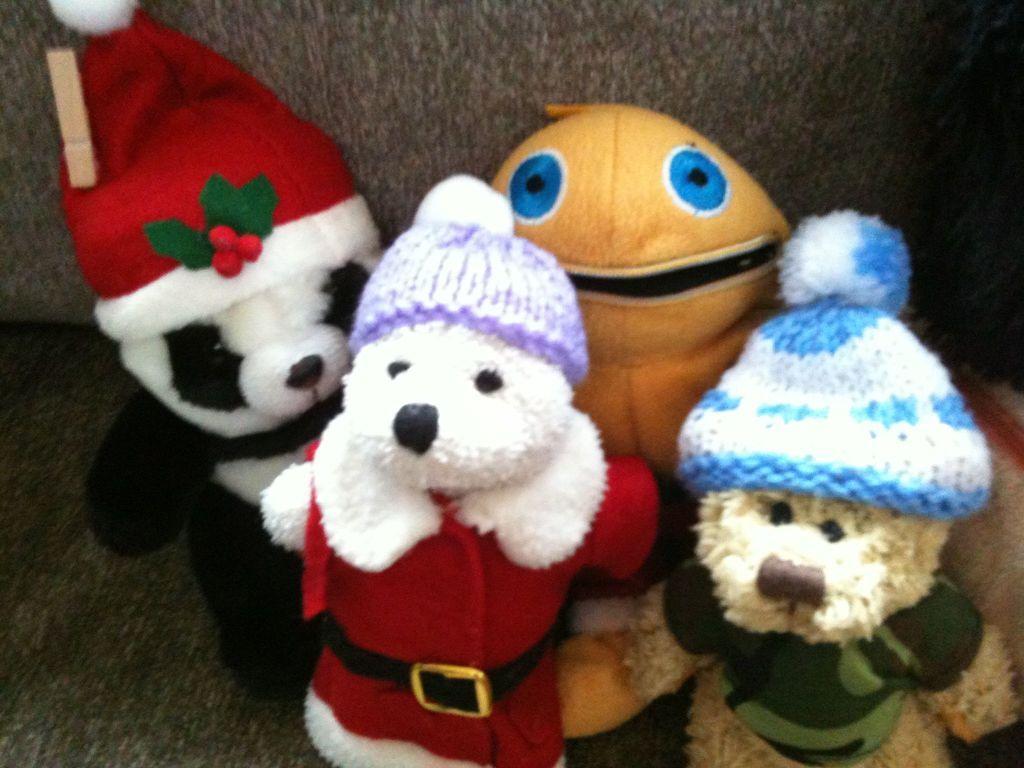Could you give a brief overview of what you see in this image? In this image, we can see toys on the couch. 